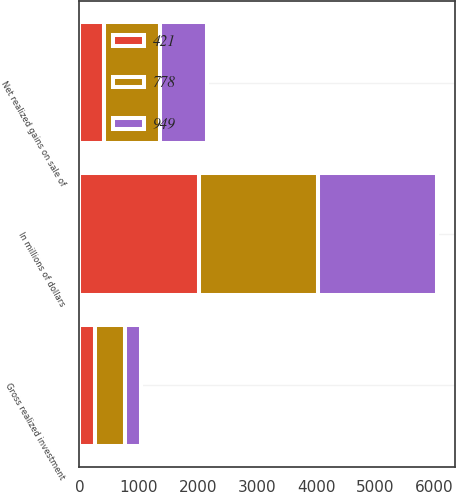Convert chart. <chart><loc_0><loc_0><loc_500><loc_500><stacked_bar_chart><ecel><fcel>In millions of dollars<fcel>Gross realized investment<fcel>Net realized gains on sale of<nl><fcel>421<fcel>2018<fcel>261<fcel>421<nl><fcel>949<fcel>2017<fcel>261<fcel>778<nl><fcel>778<fcel>2016<fcel>511<fcel>949<nl></chart> 